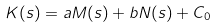<formula> <loc_0><loc_0><loc_500><loc_500>K ( s ) = a M ( s ) + b N ( s ) + C _ { 0 }</formula> 